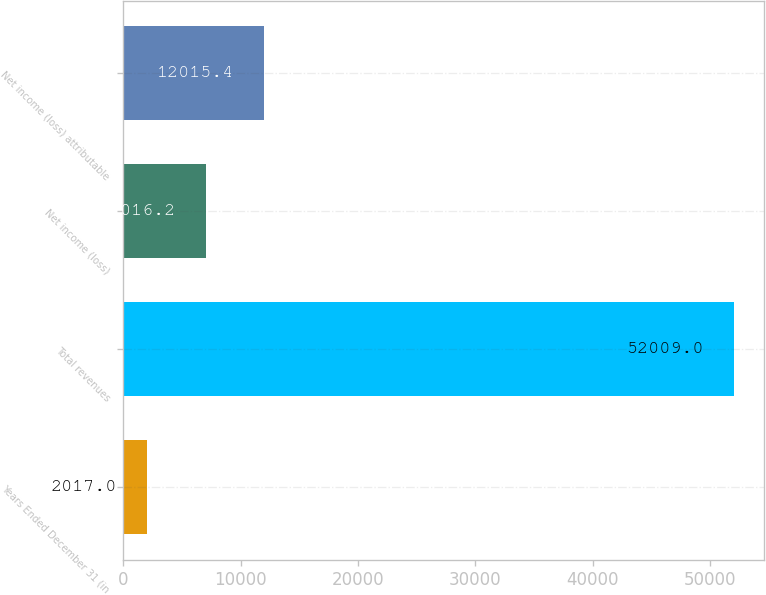Convert chart to OTSL. <chart><loc_0><loc_0><loc_500><loc_500><bar_chart><fcel>Years Ended December 31 (in<fcel>Total revenues<fcel>Net income (loss)<fcel>Net income (loss) attributable<nl><fcel>2017<fcel>52009<fcel>7016.2<fcel>12015.4<nl></chart> 